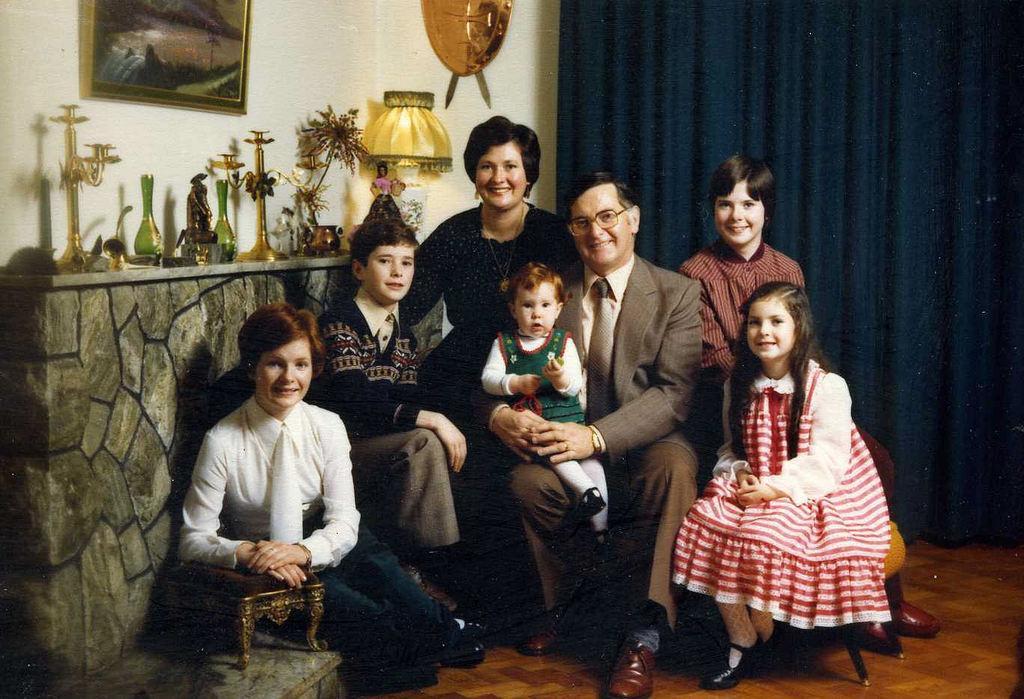Could you give a brief overview of what you see in this image? In this image, we can see persons and kids wearing clothes. There are objects on the left side of the image. There is a photo frame on the wall. There are swords with a shield at the top of the image. There is a curtain on the right side of the image. There is a stool in the bottom left of the image. 